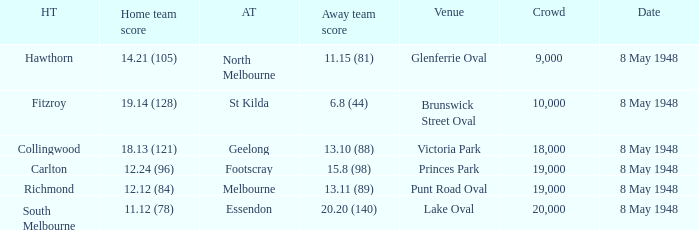Which home team has a score of 11.12 (78)? South Melbourne. 